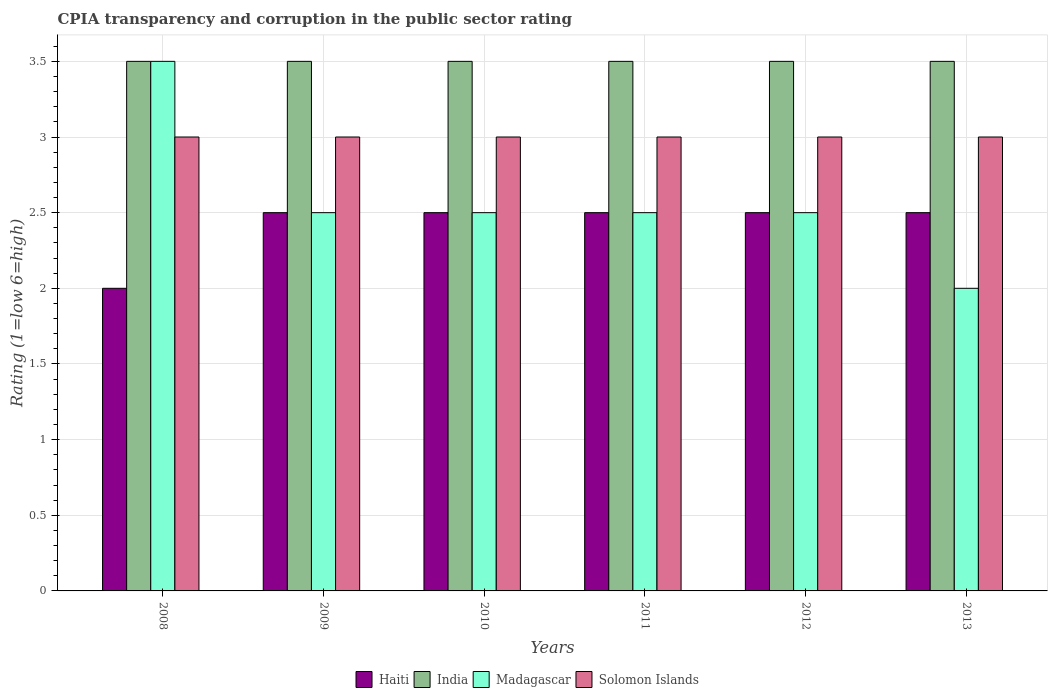How many groups of bars are there?
Provide a succinct answer. 6. Are the number of bars on each tick of the X-axis equal?
Your answer should be very brief. Yes. How many bars are there on the 6th tick from the right?
Your answer should be very brief. 4. What is the label of the 1st group of bars from the left?
Make the answer very short. 2008. In how many cases, is the number of bars for a given year not equal to the number of legend labels?
Give a very brief answer. 0. What is the CPIA rating in Madagascar in 2008?
Your answer should be compact. 3.5. Across all years, what is the minimum CPIA rating in Solomon Islands?
Your response must be concise. 3. In which year was the CPIA rating in Haiti maximum?
Provide a short and direct response. 2009. What is the total CPIA rating in Solomon Islands in the graph?
Offer a terse response. 18. What is the difference between the CPIA rating in Madagascar in 2008 and that in 2011?
Offer a terse response. 1. What is the average CPIA rating in Solomon Islands per year?
Your answer should be very brief. 3. Is the CPIA rating in Madagascar in 2010 less than that in 2012?
Give a very brief answer. No. What is the difference between the highest and the lowest CPIA rating in Haiti?
Your answer should be compact. 0.5. In how many years, is the CPIA rating in Solomon Islands greater than the average CPIA rating in Solomon Islands taken over all years?
Make the answer very short. 0. Is it the case that in every year, the sum of the CPIA rating in Haiti and CPIA rating in Solomon Islands is greater than the sum of CPIA rating in India and CPIA rating in Madagascar?
Ensure brevity in your answer.  No. What does the 3rd bar from the left in 2012 represents?
Provide a short and direct response. Madagascar. What does the 1st bar from the right in 2010 represents?
Your answer should be compact. Solomon Islands. Is it the case that in every year, the sum of the CPIA rating in Haiti and CPIA rating in Solomon Islands is greater than the CPIA rating in India?
Ensure brevity in your answer.  Yes. Are all the bars in the graph horizontal?
Ensure brevity in your answer.  No. What is the difference between two consecutive major ticks on the Y-axis?
Your response must be concise. 0.5. Are the values on the major ticks of Y-axis written in scientific E-notation?
Keep it short and to the point. No. Does the graph contain any zero values?
Give a very brief answer. No. Where does the legend appear in the graph?
Your answer should be compact. Bottom center. How many legend labels are there?
Keep it short and to the point. 4. What is the title of the graph?
Ensure brevity in your answer.  CPIA transparency and corruption in the public sector rating. What is the label or title of the Y-axis?
Your answer should be very brief. Rating (1=low 6=high). What is the Rating (1=low 6=high) of Madagascar in 2008?
Your answer should be very brief. 3.5. What is the Rating (1=low 6=high) of Haiti in 2009?
Make the answer very short. 2.5. What is the Rating (1=low 6=high) in India in 2009?
Keep it short and to the point. 3.5. What is the Rating (1=low 6=high) in Solomon Islands in 2009?
Keep it short and to the point. 3. What is the Rating (1=low 6=high) in Haiti in 2010?
Your answer should be very brief. 2.5. What is the Rating (1=low 6=high) in Solomon Islands in 2010?
Offer a very short reply. 3. What is the Rating (1=low 6=high) of Haiti in 2011?
Provide a succinct answer. 2.5. What is the Rating (1=low 6=high) in Solomon Islands in 2011?
Offer a terse response. 3. What is the Rating (1=low 6=high) of India in 2012?
Your answer should be compact. 3.5. What is the Rating (1=low 6=high) of Solomon Islands in 2012?
Your response must be concise. 3. What is the Rating (1=low 6=high) in India in 2013?
Offer a very short reply. 3.5. What is the Rating (1=low 6=high) of Madagascar in 2013?
Give a very brief answer. 2. Across all years, what is the maximum Rating (1=low 6=high) of India?
Provide a short and direct response. 3.5. Across all years, what is the minimum Rating (1=low 6=high) of Haiti?
Keep it short and to the point. 2. Across all years, what is the minimum Rating (1=low 6=high) of India?
Make the answer very short. 3.5. Across all years, what is the minimum Rating (1=low 6=high) of Madagascar?
Your answer should be very brief. 2. What is the difference between the Rating (1=low 6=high) in Madagascar in 2008 and that in 2009?
Your answer should be very brief. 1. What is the difference between the Rating (1=low 6=high) of Solomon Islands in 2008 and that in 2009?
Your answer should be very brief. 0. What is the difference between the Rating (1=low 6=high) of Madagascar in 2008 and that in 2010?
Offer a very short reply. 1. What is the difference between the Rating (1=low 6=high) of Solomon Islands in 2008 and that in 2010?
Your answer should be very brief. 0. What is the difference between the Rating (1=low 6=high) of Haiti in 2008 and that in 2011?
Give a very brief answer. -0.5. What is the difference between the Rating (1=low 6=high) of Solomon Islands in 2008 and that in 2011?
Provide a succinct answer. 0. What is the difference between the Rating (1=low 6=high) of Haiti in 2008 and that in 2012?
Offer a very short reply. -0.5. What is the difference between the Rating (1=low 6=high) in India in 2009 and that in 2010?
Give a very brief answer. 0. What is the difference between the Rating (1=low 6=high) of Madagascar in 2009 and that in 2010?
Your response must be concise. 0. What is the difference between the Rating (1=low 6=high) in Solomon Islands in 2009 and that in 2010?
Give a very brief answer. 0. What is the difference between the Rating (1=low 6=high) in Haiti in 2009 and that in 2011?
Provide a succinct answer. 0. What is the difference between the Rating (1=low 6=high) of India in 2009 and that in 2011?
Provide a succinct answer. 0. What is the difference between the Rating (1=low 6=high) of Madagascar in 2009 and that in 2011?
Offer a very short reply. 0. What is the difference between the Rating (1=low 6=high) in Haiti in 2009 and that in 2012?
Keep it short and to the point. 0. What is the difference between the Rating (1=low 6=high) of Haiti in 2009 and that in 2013?
Keep it short and to the point. 0. What is the difference between the Rating (1=low 6=high) of India in 2009 and that in 2013?
Your answer should be compact. 0. What is the difference between the Rating (1=low 6=high) of India in 2010 and that in 2011?
Make the answer very short. 0. What is the difference between the Rating (1=low 6=high) of Solomon Islands in 2010 and that in 2011?
Your answer should be very brief. 0. What is the difference between the Rating (1=low 6=high) in Haiti in 2010 and that in 2012?
Provide a short and direct response. 0. What is the difference between the Rating (1=low 6=high) in India in 2010 and that in 2012?
Your answer should be compact. 0. What is the difference between the Rating (1=low 6=high) in Madagascar in 2010 and that in 2012?
Keep it short and to the point. 0. What is the difference between the Rating (1=low 6=high) of Solomon Islands in 2010 and that in 2013?
Give a very brief answer. 0. What is the difference between the Rating (1=low 6=high) of India in 2011 and that in 2012?
Keep it short and to the point. 0. What is the difference between the Rating (1=low 6=high) of Madagascar in 2011 and that in 2012?
Your response must be concise. 0. What is the difference between the Rating (1=low 6=high) in Solomon Islands in 2012 and that in 2013?
Your answer should be compact. 0. What is the difference between the Rating (1=low 6=high) of Haiti in 2008 and the Rating (1=low 6=high) of India in 2009?
Your response must be concise. -1.5. What is the difference between the Rating (1=low 6=high) in Haiti in 2008 and the Rating (1=low 6=high) in Madagascar in 2009?
Make the answer very short. -0.5. What is the difference between the Rating (1=low 6=high) in Haiti in 2008 and the Rating (1=low 6=high) in Madagascar in 2010?
Provide a short and direct response. -0.5. What is the difference between the Rating (1=low 6=high) of Haiti in 2008 and the Rating (1=low 6=high) of Solomon Islands in 2010?
Your answer should be compact. -1. What is the difference between the Rating (1=low 6=high) of India in 2008 and the Rating (1=low 6=high) of Madagascar in 2010?
Give a very brief answer. 1. What is the difference between the Rating (1=low 6=high) of India in 2008 and the Rating (1=low 6=high) of Solomon Islands in 2010?
Offer a terse response. 0.5. What is the difference between the Rating (1=low 6=high) of Haiti in 2008 and the Rating (1=low 6=high) of Madagascar in 2011?
Make the answer very short. -0.5. What is the difference between the Rating (1=low 6=high) of India in 2008 and the Rating (1=low 6=high) of Madagascar in 2011?
Your answer should be compact. 1. What is the difference between the Rating (1=low 6=high) in Haiti in 2008 and the Rating (1=low 6=high) in India in 2012?
Your answer should be compact. -1.5. What is the difference between the Rating (1=low 6=high) in India in 2008 and the Rating (1=low 6=high) in Solomon Islands in 2012?
Your answer should be very brief. 0.5. What is the difference between the Rating (1=low 6=high) of Haiti in 2008 and the Rating (1=low 6=high) of India in 2013?
Your answer should be very brief. -1.5. What is the difference between the Rating (1=low 6=high) of Haiti in 2008 and the Rating (1=low 6=high) of Madagascar in 2013?
Ensure brevity in your answer.  0. What is the difference between the Rating (1=low 6=high) of Haiti in 2008 and the Rating (1=low 6=high) of Solomon Islands in 2013?
Make the answer very short. -1. What is the difference between the Rating (1=low 6=high) of India in 2008 and the Rating (1=low 6=high) of Madagascar in 2013?
Your answer should be compact. 1.5. What is the difference between the Rating (1=low 6=high) in India in 2008 and the Rating (1=low 6=high) in Solomon Islands in 2013?
Offer a very short reply. 0.5. What is the difference between the Rating (1=low 6=high) of Haiti in 2009 and the Rating (1=low 6=high) of Madagascar in 2010?
Provide a succinct answer. 0. What is the difference between the Rating (1=low 6=high) in Haiti in 2009 and the Rating (1=low 6=high) in Solomon Islands in 2010?
Offer a very short reply. -0.5. What is the difference between the Rating (1=low 6=high) in India in 2009 and the Rating (1=low 6=high) in Solomon Islands in 2010?
Provide a succinct answer. 0.5. What is the difference between the Rating (1=low 6=high) of Madagascar in 2009 and the Rating (1=low 6=high) of Solomon Islands in 2010?
Keep it short and to the point. -0.5. What is the difference between the Rating (1=low 6=high) of Haiti in 2009 and the Rating (1=low 6=high) of Solomon Islands in 2011?
Offer a very short reply. -0.5. What is the difference between the Rating (1=low 6=high) in India in 2009 and the Rating (1=low 6=high) in Madagascar in 2011?
Your answer should be compact. 1. What is the difference between the Rating (1=low 6=high) in India in 2009 and the Rating (1=low 6=high) in Solomon Islands in 2011?
Make the answer very short. 0.5. What is the difference between the Rating (1=low 6=high) in Madagascar in 2009 and the Rating (1=low 6=high) in Solomon Islands in 2011?
Your answer should be compact. -0.5. What is the difference between the Rating (1=low 6=high) in Haiti in 2009 and the Rating (1=low 6=high) in Madagascar in 2012?
Your answer should be compact. 0. What is the difference between the Rating (1=low 6=high) in Haiti in 2009 and the Rating (1=low 6=high) in Solomon Islands in 2012?
Your response must be concise. -0.5. What is the difference between the Rating (1=low 6=high) in India in 2009 and the Rating (1=low 6=high) in Madagascar in 2012?
Make the answer very short. 1. What is the difference between the Rating (1=low 6=high) of India in 2009 and the Rating (1=low 6=high) of Solomon Islands in 2012?
Provide a short and direct response. 0.5. What is the difference between the Rating (1=low 6=high) in Haiti in 2009 and the Rating (1=low 6=high) in Solomon Islands in 2013?
Offer a terse response. -0.5. What is the difference between the Rating (1=low 6=high) of India in 2009 and the Rating (1=low 6=high) of Madagascar in 2013?
Make the answer very short. 1.5. What is the difference between the Rating (1=low 6=high) of India in 2009 and the Rating (1=low 6=high) of Solomon Islands in 2013?
Your answer should be compact. 0.5. What is the difference between the Rating (1=low 6=high) of Haiti in 2010 and the Rating (1=low 6=high) of India in 2011?
Provide a succinct answer. -1. What is the difference between the Rating (1=low 6=high) of Haiti in 2010 and the Rating (1=low 6=high) of Madagascar in 2011?
Offer a terse response. 0. What is the difference between the Rating (1=low 6=high) in Haiti in 2010 and the Rating (1=low 6=high) in Solomon Islands in 2011?
Offer a very short reply. -0.5. What is the difference between the Rating (1=low 6=high) of India in 2010 and the Rating (1=low 6=high) of Madagascar in 2011?
Provide a succinct answer. 1. What is the difference between the Rating (1=low 6=high) in India in 2010 and the Rating (1=low 6=high) in Solomon Islands in 2011?
Offer a terse response. 0.5. What is the difference between the Rating (1=low 6=high) in Madagascar in 2010 and the Rating (1=low 6=high) in Solomon Islands in 2011?
Keep it short and to the point. -0.5. What is the difference between the Rating (1=low 6=high) in Haiti in 2010 and the Rating (1=low 6=high) in India in 2012?
Offer a very short reply. -1. What is the difference between the Rating (1=low 6=high) of Haiti in 2010 and the Rating (1=low 6=high) of Madagascar in 2012?
Offer a very short reply. 0. What is the difference between the Rating (1=low 6=high) in Haiti in 2010 and the Rating (1=low 6=high) in Solomon Islands in 2012?
Offer a very short reply. -0.5. What is the difference between the Rating (1=low 6=high) of India in 2010 and the Rating (1=low 6=high) of Madagascar in 2012?
Keep it short and to the point. 1. What is the difference between the Rating (1=low 6=high) of India in 2010 and the Rating (1=low 6=high) of Solomon Islands in 2012?
Your answer should be compact. 0.5. What is the difference between the Rating (1=low 6=high) in Haiti in 2010 and the Rating (1=low 6=high) in India in 2013?
Your answer should be compact. -1. What is the difference between the Rating (1=low 6=high) in Haiti in 2010 and the Rating (1=low 6=high) in Madagascar in 2013?
Offer a terse response. 0.5. What is the difference between the Rating (1=low 6=high) of India in 2010 and the Rating (1=low 6=high) of Madagascar in 2013?
Provide a short and direct response. 1.5. What is the difference between the Rating (1=low 6=high) in Haiti in 2011 and the Rating (1=low 6=high) in India in 2012?
Make the answer very short. -1. What is the difference between the Rating (1=low 6=high) of Haiti in 2011 and the Rating (1=low 6=high) of Madagascar in 2012?
Provide a short and direct response. 0. What is the difference between the Rating (1=low 6=high) of India in 2011 and the Rating (1=low 6=high) of Madagascar in 2012?
Offer a terse response. 1. What is the difference between the Rating (1=low 6=high) in India in 2011 and the Rating (1=low 6=high) in Solomon Islands in 2012?
Provide a succinct answer. 0.5. What is the difference between the Rating (1=low 6=high) in Haiti in 2011 and the Rating (1=low 6=high) in India in 2013?
Provide a short and direct response. -1. What is the difference between the Rating (1=low 6=high) in Haiti in 2011 and the Rating (1=low 6=high) in Madagascar in 2013?
Your answer should be compact. 0.5. What is the difference between the Rating (1=low 6=high) of Haiti in 2011 and the Rating (1=low 6=high) of Solomon Islands in 2013?
Your answer should be very brief. -0.5. What is the difference between the Rating (1=low 6=high) of India in 2011 and the Rating (1=low 6=high) of Madagascar in 2013?
Your response must be concise. 1.5. What is the difference between the Rating (1=low 6=high) in India in 2011 and the Rating (1=low 6=high) in Solomon Islands in 2013?
Your answer should be compact. 0.5. What is the difference between the Rating (1=low 6=high) in India in 2012 and the Rating (1=low 6=high) in Madagascar in 2013?
Your answer should be compact. 1.5. What is the average Rating (1=low 6=high) of Haiti per year?
Offer a terse response. 2.42. What is the average Rating (1=low 6=high) of Madagascar per year?
Make the answer very short. 2.58. In the year 2008, what is the difference between the Rating (1=low 6=high) of Haiti and Rating (1=low 6=high) of Solomon Islands?
Give a very brief answer. -1. In the year 2008, what is the difference between the Rating (1=low 6=high) in India and Rating (1=low 6=high) in Solomon Islands?
Provide a succinct answer. 0.5. In the year 2008, what is the difference between the Rating (1=low 6=high) of Madagascar and Rating (1=low 6=high) of Solomon Islands?
Make the answer very short. 0.5. In the year 2009, what is the difference between the Rating (1=low 6=high) in Haiti and Rating (1=low 6=high) in Madagascar?
Offer a very short reply. 0. In the year 2009, what is the difference between the Rating (1=low 6=high) of Haiti and Rating (1=low 6=high) of Solomon Islands?
Ensure brevity in your answer.  -0.5. In the year 2009, what is the difference between the Rating (1=low 6=high) of India and Rating (1=low 6=high) of Madagascar?
Offer a terse response. 1. In the year 2009, what is the difference between the Rating (1=low 6=high) of India and Rating (1=low 6=high) of Solomon Islands?
Provide a succinct answer. 0.5. In the year 2009, what is the difference between the Rating (1=low 6=high) of Madagascar and Rating (1=low 6=high) of Solomon Islands?
Your answer should be very brief. -0.5. In the year 2010, what is the difference between the Rating (1=low 6=high) in Haiti and Rating (1=low 6=high) in India?
Make the answer very short. -1. In the year 2010, what is the difference between the Rating (1=low 6=high) in Haiti and Rating (1=low 6=high) in Madagascar?
Offer a terse response. 0. In the year 2010, what is the difference between the Rating (1=low 6=high) of India and Rating (1=low 6=high) of Madagascar?
Offer a terse response. 1. In the year 2010, what is the difference between the Rating (1=low 6=high) in India and Rating (1=low 6=high) in Solomon Islands?
Provide a short and direct response. 0.5. In the year 2011, what is the difference between the Rating (1=low 6=high) in Haiti and Rating (1=low 6=high) in Madagascar?
Keep it short and to the point. 0. In the year 2011, what is the difference between the Rating (1=low 6=high) of Haiti and Rating (1=low 6=high) of Solomon Islands?
Keep it short and to the point. -0.5. In the year 2012, what is the difference between the Rating (1=low 6=high) in Haiti and Rating (1=low 6=high) in India?
Offer a very short reply. -1. In the year 2012, what is the difference between the Rating (1=low 6=high) in India and Rating (1=low 6=high) in Solomon Islands?
Your answer should be compact. 0.5. In the year 2012, what is the difference between the Rating (1=low 6=high) in Madagascar and Rating (1=low 6=high) in Solomon Islands?
Provide a short and direct response. -0.5. In the year 2013, what is the difference between the Rating (1=low 6=high) in India and Rating (1=low 6=high) in Madagascar?
Make the answer very short. 1.5. In the year 2013, what is the difference between the Rating (1=low 6=high) of Madagascar and Rating (1=low 6=high) of Solomon Islands?
Your response must be concise. -1. What is the ratio of the Rating (1=low 6=high) of Haiti in 2008 to that in 2009?
Provide a succinct answer. 0.8. What is the ratio of the Rating (1=low 6=high) in India in 2008 to that in 2009?
Your response must be concise. 1. What is the ratio of the Rating (1=low 6=high) of Madagascar in 2008 to that in 2009?
Your answer should be very brief. 1.4. What is the ratio of the Rating (1=low 6=high) in Solomon Islands in 2008 to that in 2009?
Your response must be concise. 1. What is the ratio of the Rating (1=low 6=high) of Madagascar in 2008 to that in 2010?
Your response must be concise. 1.4. What is the ratio of the Rating (1=low 6=high) in Haiti in 2008 to that in 2011?
Provide a succinct answer. 0.8. What is the ratio of the Rating (1=low 6=high) of Haiti in 2008 to that in 2012?
Your answer should be very brief. 0.8. What is the ratio of the Rating (1=low 6=high) of India in 2008 to that in 2012?
Make the answer very short. 1. What is the ratio of the Rating (1=low 6=high) of Madagascar in 2008 to that in 2012?
Provide a succinct answer. 1.4. What is the ratio of the Rating (1=low 6=high) of Solomon Islands in 2008 to that in 2012?
Ensure brevity in your answer.  1. What is the ratio of the Rating (1=low 6=high) of India in 2008 to that in 2013?
Keep it short and to the point. 1. What is the ratio of the Rating (1=low 6=high) in Solomon Islands in 2009 to that in 2010?
Keep it short and to the point. 1. What is the ratio of the Rating (1=low 6=high) in India in 2009 to that in 2011?
Provide a short and direct response. 1. What is the ratio of the Rating (1=low 6=high) in Madagascar in 2009 to that in 2011?
Your response must be concise. 1. What is the ratio of the Rating (1=low 6=high) in Haiti in 2009 to that in 2012?
Offer a terse response. 1. What is the ratio of the Rating (1=low 6=high) of India in 2009 to that in 2012?
Make the answer very short. 1. What is the ratio of the Rating (1=low 6=high) of Madagascar in 2009 to that in 2012?
Offer a terse response. 1. What is the ratio of the Rating (1=low 6=high) of Haiti in 2009 to that in 2013?
Offer a very short reply. 1. What is the ratio of the Rating (1=low 6=high) of Solomon Islands in 2009 to that in 2013?
Offer a terse response. 1. What is the ratio of the Rating (1=low 6=high) of Solomon Islands in 2010 to that in 2011?
Ensure brevity in your answer.  1. What is the ratio of the Rating (1=low 6=high) in Madagascar in 2010 to that in 2012?
Provide a succinct answer. 1. What is the ratio of the Rating (1=low 6=high) of Solomon Islands in 2010 to that in 2012?
Ensure brevity in your answer.  1. What is the ratio of the Rating (1=low 6=high) of Madagascar in 2010 to that in 2013?
Give a very brief answer. 1.25. What is the ratio of the Rating (1=low 6=high) of Haiti in 2011 to that in 2012?
Provide a succinct answer. 1. What is the ratio of the Rating (1=low 6=high) of Haiti in 2011 to that in 2013?
Provide a short and direct response. 1. What is the ratio of the Rating (1=low 6=high) in India in 2011 to that in 2013?
Your answer should be very brief. 1. What is the ratio of the Rating (1=low 6=high) in Solomon Islands in 2011 to that in 2013?
Give a very brief answer. 1. What is the ratio of the Rating (1=low 6=high) in Madagascar in 2012 to that in 2013?
Make the answer very short. 1.25. What is the ratio of the Rating (1=low 6=high) of Solomon Islands in 2012 to that in 2013?
Make the answer very short. 1. What is the difference between the highest and the second highest Rating (1=low 6=high) of Haiti?
Offer a very short reply. 0. What is the difference between the highest and the second highest Rating (1=low 6=high) in Solomon Islands?
Your answer should be compact. 0. What is the difference between the highest and the lowest Rating (1=low 6=high) in India?
Your answer should be compact. 0. What is the difference between the highest and the lowest Rating (1=low 6=high) of Solomon Islands?
Offer a very short reply. 0. 